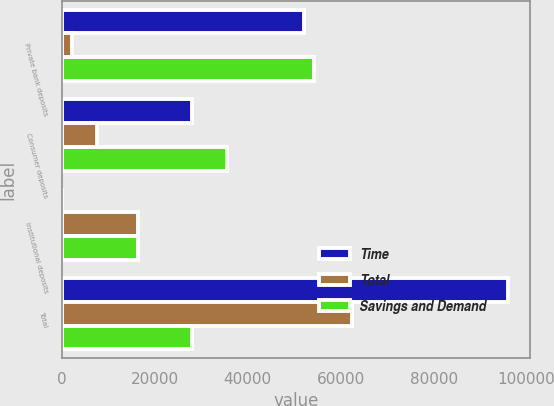Convert chart to OTSL. <chart><loc_0><loc_0><loc_500><loc_500><stacked_bar_chart><ecel><fcel>Private bank deposits<fcel>Consumer deposits<fcel>Institutional deposits<fcel>Total<nl><fcel>Time<fcel>52028<fcel>27987<fcel>1<fcel>95919<nl><fcel>Total<fcel>2311<fcel>7641<fcel>16510<fcel>62338<nl><fcel>Savings and Demand<fcel>54339<fcel>35628<fcel>16511<fcel>27987<nl></chart> 